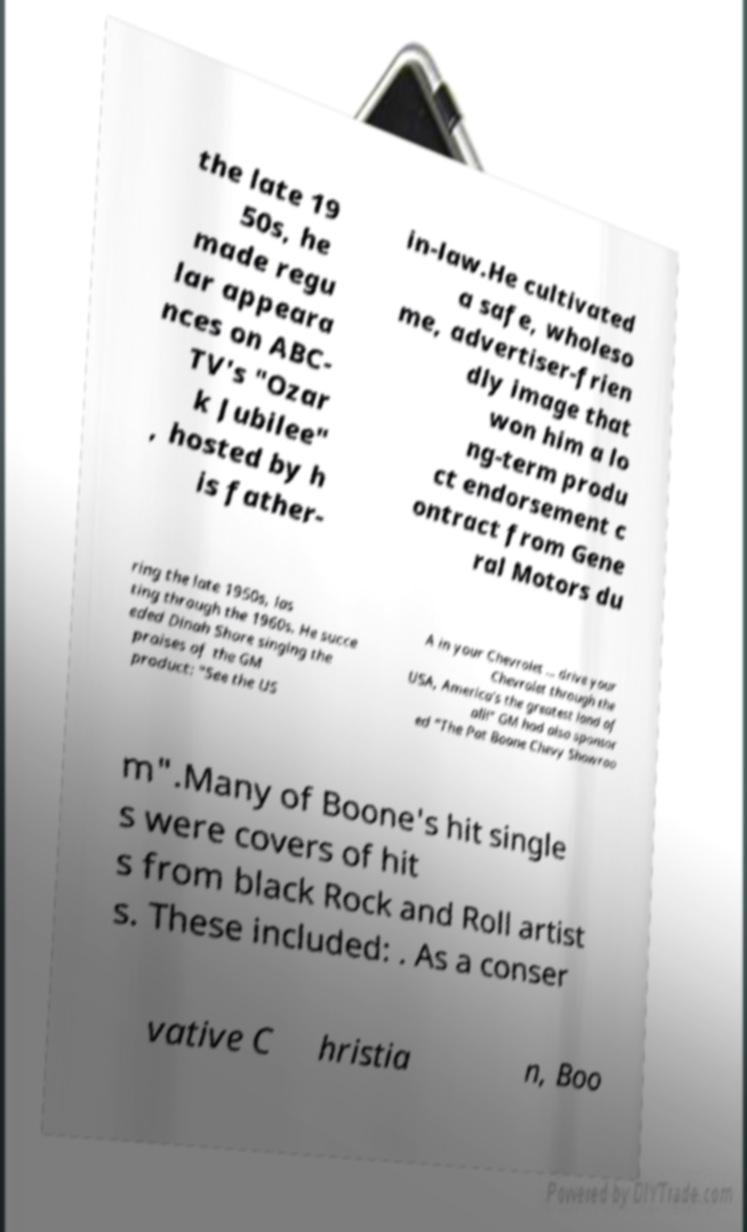Can you read and provide the text displayed in the image?This photo seems to have some interesting text. Can you extract and type it out for me? the late 19 50s, he made regu lar appeara nces on ABC- TV's "Ozar k Jubilee" , hosted by h is father- in-law.He cultivated a safe, wholeso me, advertiser-frien dly image that won him a lo ng-term produ ct endorsement c ontract from Gene ral Motors du ring the late 1950s, las ting through the 1960s. He succe eded Dinah Shore singing the praises of the GM product: "See the US A in your Chevrolet ... drive your Chevrolet through the USA, America's the greatest land of all!" GM had also sponsor ed "The Pat Boone Chevy Showroo m".Many of Boone's hit single s were covers of hit s from black Rock and Roll artist s. These included: . As a conser vative C hristia n, Boo 